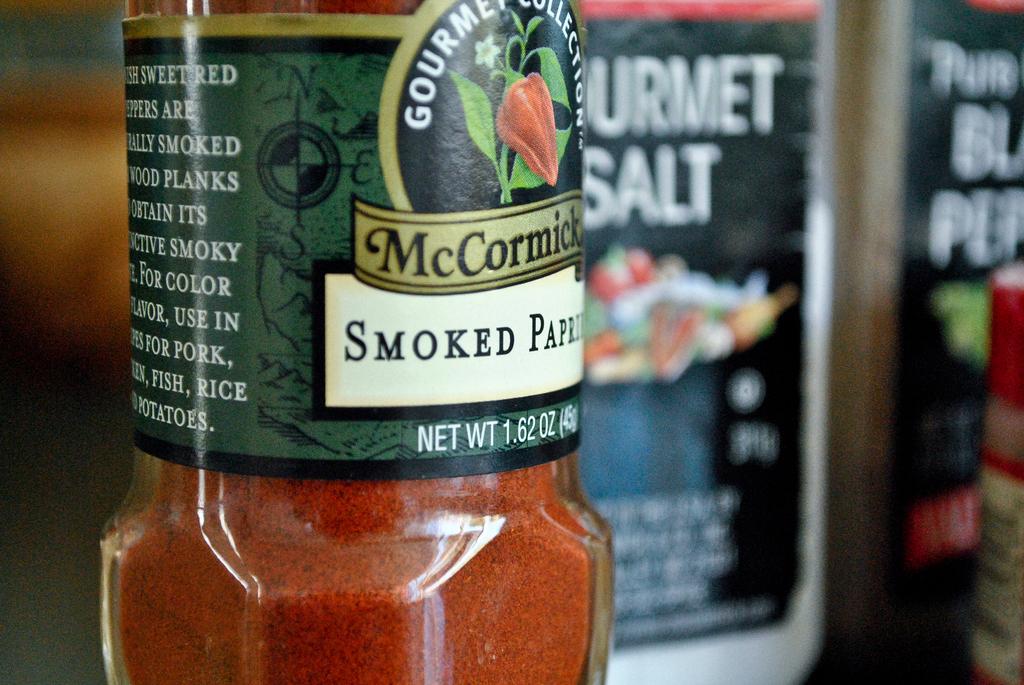What is the net weight of the spices?
Keep it short and to the point. 1.62 oz. 